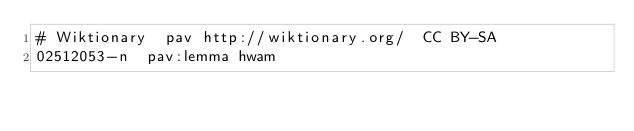Convert code to text. <code><loc_0><loc_0><loc_500><loc_500><_SQL_># Wiktionary	pav	http://wiktionary.org/	CC BY-SA
02512053-n	pav:lemma	hwam
</code> 